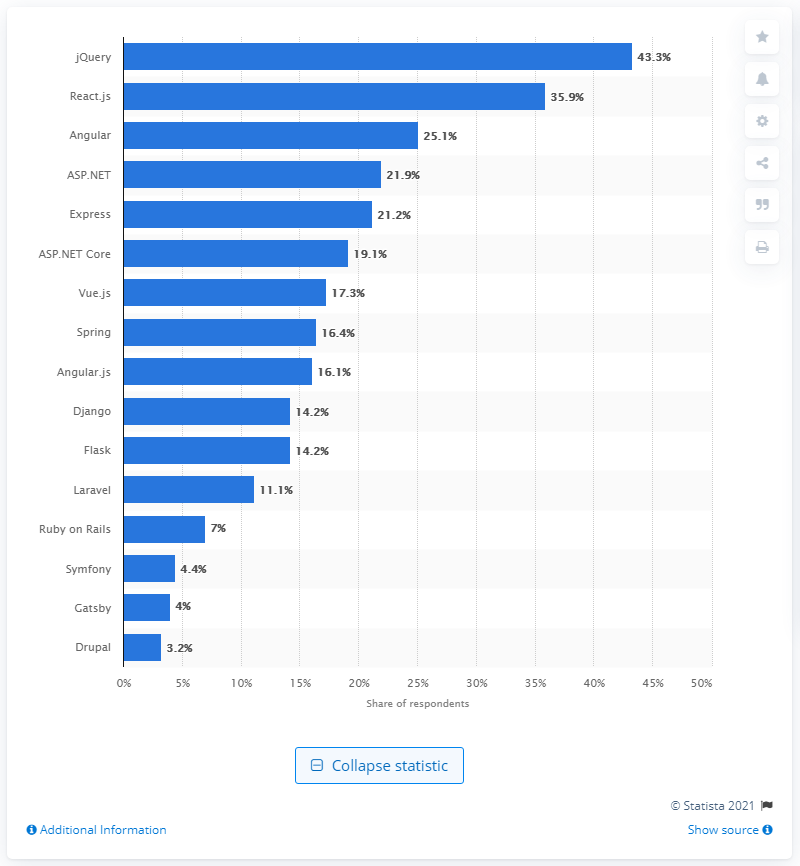Which technology is the most preferred according to this chart? The chart indicates that 'jQuery' is the most preferred technology among the respondents, with a 43.3% share. 